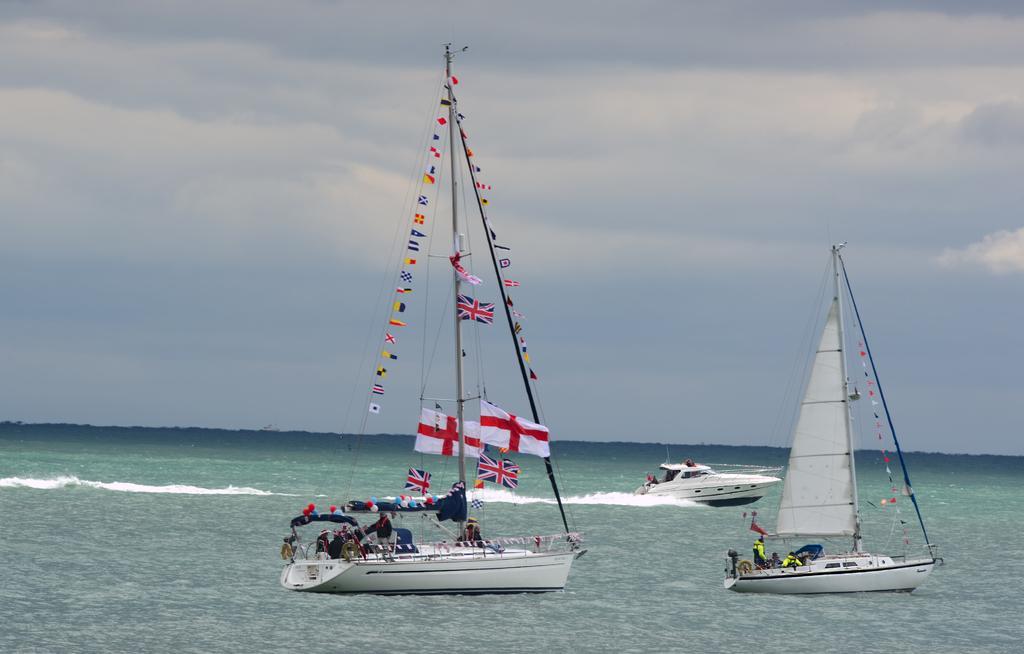Could you give a brief overview of what you see in this image? In the image there is water. On the water there are three boats. One of them is a speed boat. On the remaining two board there are poles with many flags and there are few people sitting in it. At the top of the image there is a sky with clouds. 